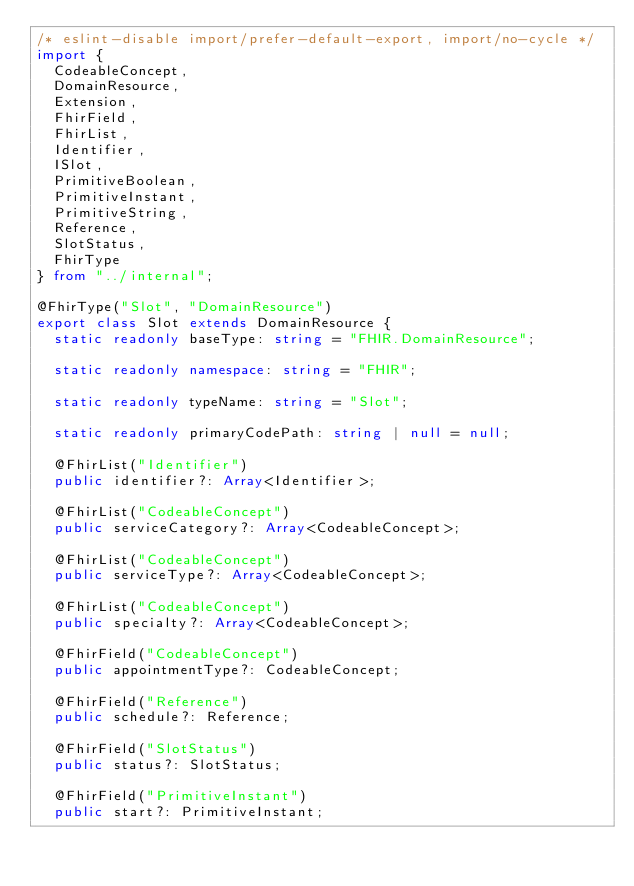Convert code to text. <code><loc_0><loc_0><loc_500><loc_500><_TypeScript_>/* eslint-disable import/prefer-default-export, import/no-cycle */
import {
  CodeableConcept,
  DomainResource,
  Extension,
  FhirField,
  FhirList,
  Identifier,
  ISlot,
  PrimitiveBoolean,
  PrimitiveInstant,
  PrimitiveString,
  Reference,
  SlotStatus,
  FhirType
} from "../internal";

@FhirType("Slot", "DomainResource")
export class Slot extends DomainResource {
  static readonly baseType: string = "FHIR.DomainResource";

  static readonly namespace: string = "FHIR";

  static readonly typeName: string = "Slot";

  static readonly primaryCodePath: string | null = null;

  @FhirList("Identifier")
  public identifier?: Array<Identifier>;

  @FhirList("CodeableConcept")
  public serviceCategory?: Array<CodeableConcept>;

  @FhirList("CodeableConcept")
  public serviceType?: Array<CodeableConcept>;

  @FhirList("CodeableConcept")
  public specialty?: Array<CodeableConcept>;

  @FhirField("CodeableConcept")
  public appointmentType?: CodeableConcept;

  @FhirField("Reference")
  public schedule?: Reference;

  @FhirField("SlotStatus")
  public status?: SlotStatus;

  @FhirField("PrimitiveInstant")
  public start?: PrimitiveInstant;
</code> 